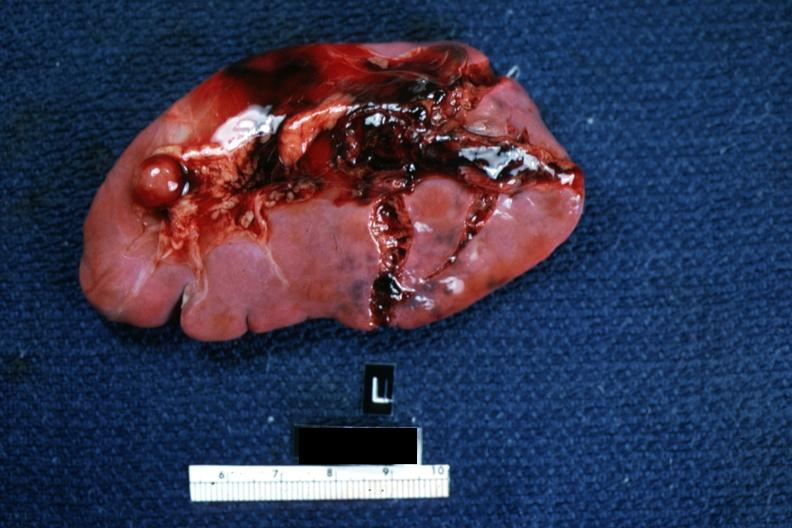where is this part in?
Answer the question using a single word or phrase. Spleen 